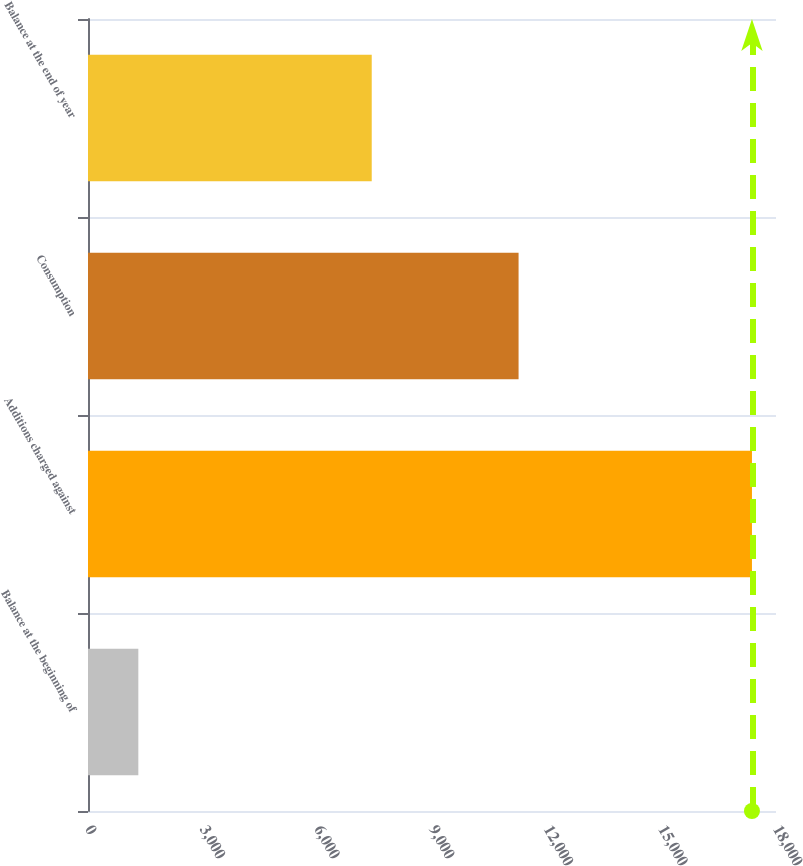Convert chart to OTSL. <chart><loc_0><loc_0><loc_500><loc_500><bar_chart><fcel>Balance at the beginning of<fcel>Additions charged against<fcel>Consumption<fcel>Balance at the end of year<nl><fcel>1317<fcel>17371<fcel>11265<fcel>7423<nl></chart> 